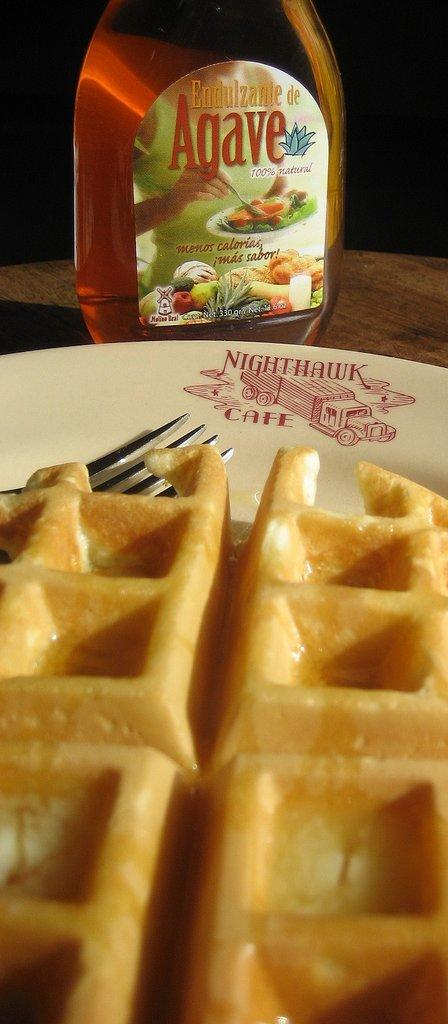What is on the plate that is visible in the image? There is food on a plate in the image. What utensil is present with the plate? The plate has a fork. What else can be seen on the table in the image? There is a bottle on the table in the image. Can you tell me how many mailboxes are present in the image? There are no mailboxes present in the image; it features a plate of food, a fork, and a bottle on a table. What type of station is the food served at? There is no mention of a station in the image or the provided facts. 